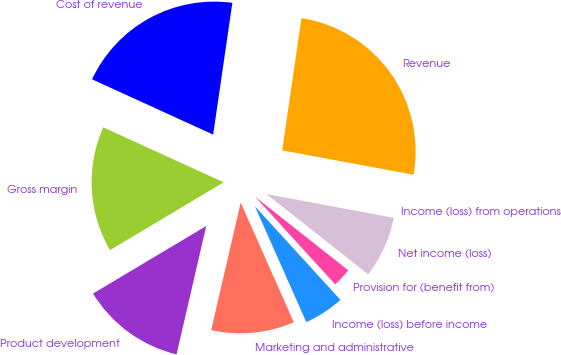<chart> <loc_0><loc_0><loc_500><loc_500><pie_chart><fcel>Revenue<fcel>Cost of revenue<fcel>Gross margin<fcel>Product development<fcel>Marketing and administrative<fcel>Income (loss) before income<fcel>Provision for (benefit from)<fcel>Net income (loss)<fcel>Income (loss) from operations<nl><fcel>25.62%<fcel>20.49%<fcel>15.38%<fcel>12.82%<fcel>10.26%<fcel>5.14%<fcel>2.58%<fcel>7.7%<fcel>0.01%<nl></chart> 